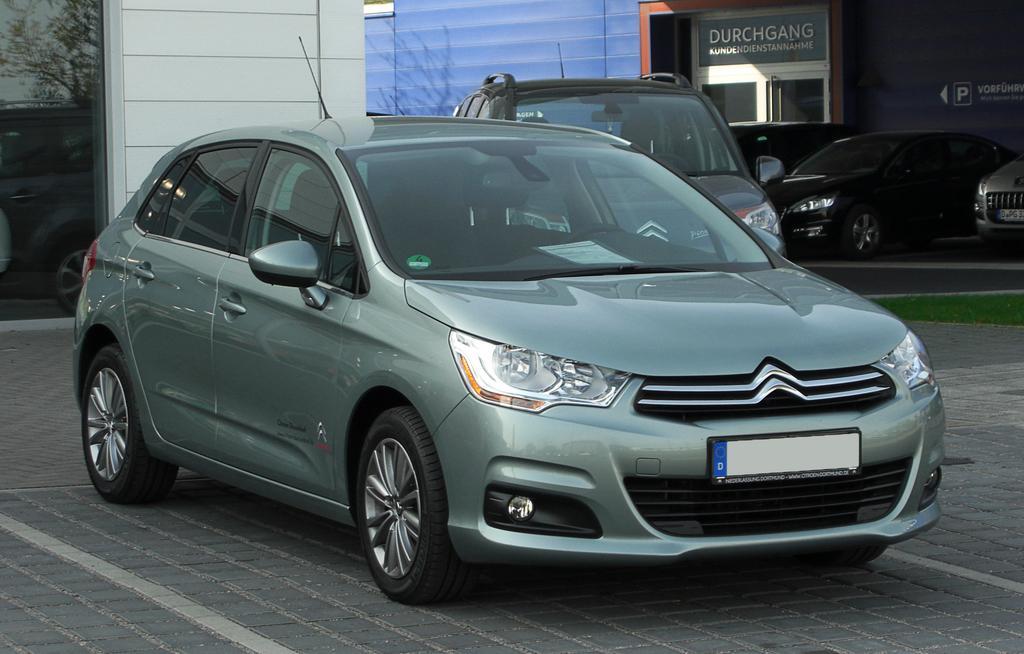In one or two sentences, can you explain what this image depicts? In this image I can see a car which is green in color on the ground. In the background I can see few other cars, the building and the glass in which I can see the reflection of a car, a tree and the sky. 